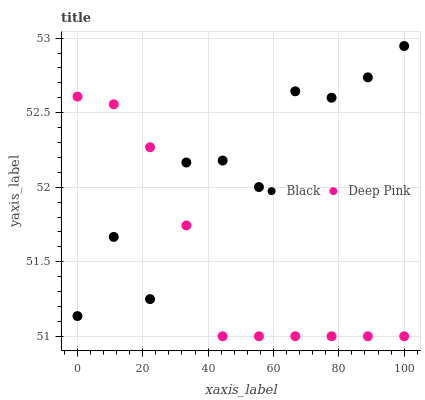Does Deep Pink have the minimum area under the curve?
Answer yes or no. Yes. Does Black have the maximum area under the curve?
Answer yes or no. Yes. Does Black have the minimum area under the curve?
Answer yes or no. No. Is Deep Pink the smoothest?
Answer yes or no. Yes. Is Black the roughest?
Answer yes or no. Yes. Is Black the smoothest?
Answer yes or no. No. Does Deep Pink have the lowest value?
Answer yes or no. Yes. Does Black have the lowest value?
Answer yes or no. No. Does Black have the highest value?
Answer yes or no. Yes. Does Deep Pink intersect Black?
Answer yes or no. Yes. Is Deep Pink less than Black?
Answer yes or no. No. Is Deep Pink greater than Black?
Answer yes or no. No. 